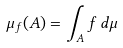Convert formula to latex. <formula><loc_0><loc_0><loc_500><loc_500>\mu _ { f } ( A ) = \int _ { A } f \, d \mu</formula> 